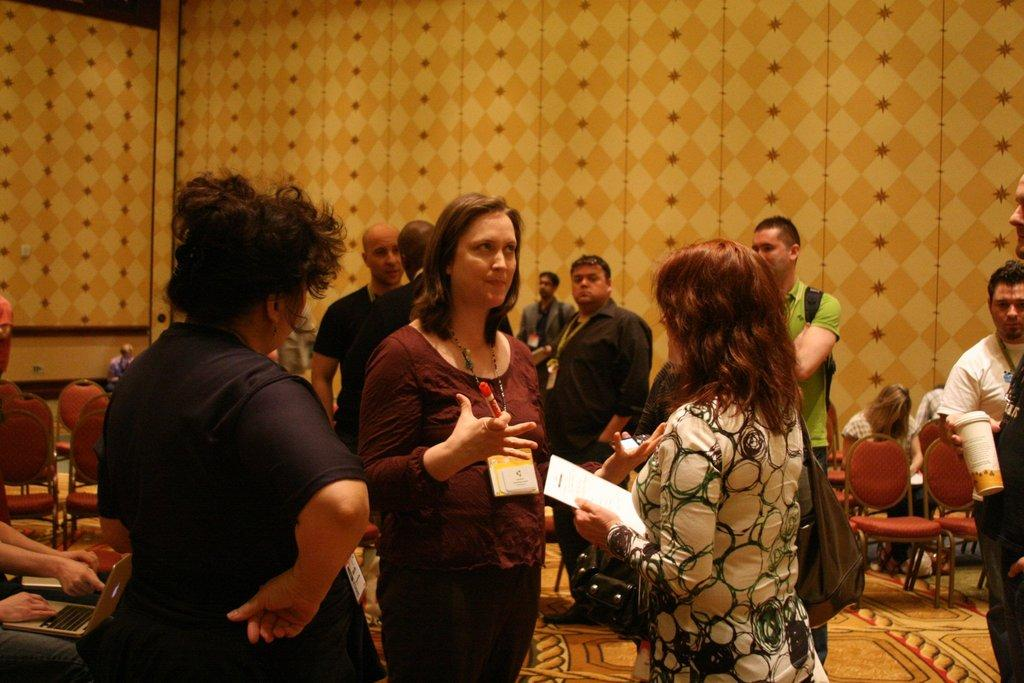What are the people in the image doing? There are persons standing and sitting in the image. Can you describe the woman in the image? The woman is carrying a sketch in her hand and talking. What is visible in the background of the image? There is a wall in the background of the image. Can you tell me how many hens are present in the image? There are no hens present in the image. What type of net is being used by the persons in the image? There is no net visible in the image. 